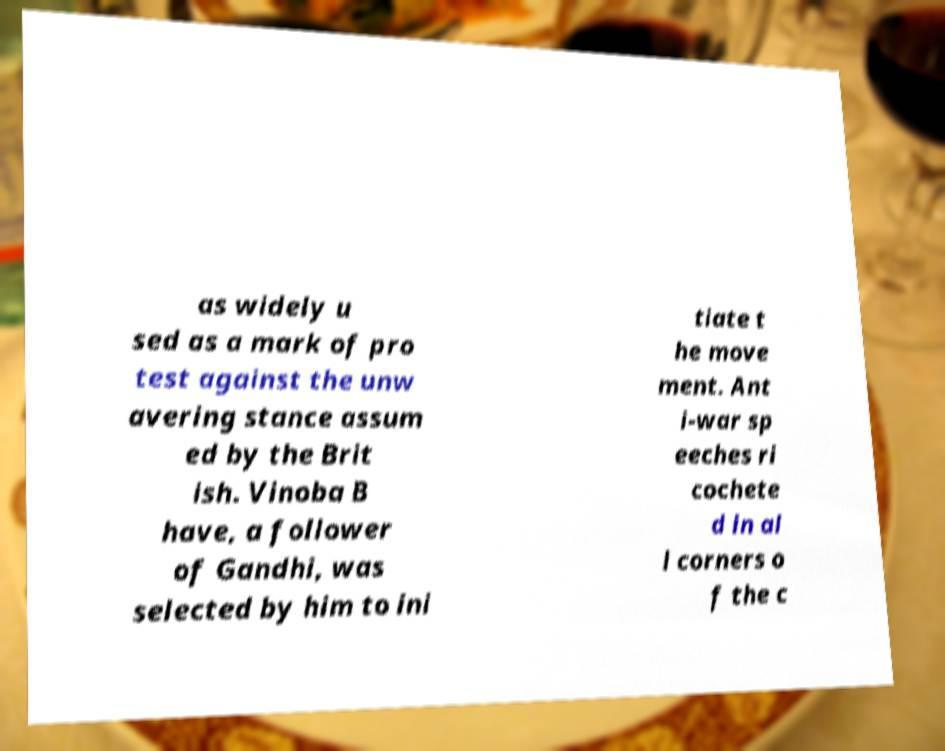What messages or text are displayed in this image? I need them in a readable, typed format. as widely u sed as a mark of pro test against the unw avering stance assum ed by the Brit ish. Vinoba B have, a follower of Gandhi, was selected by him to ini tiate t he move ment. Ant i-war sp eeches ri cochete d in al l corners o f the c 